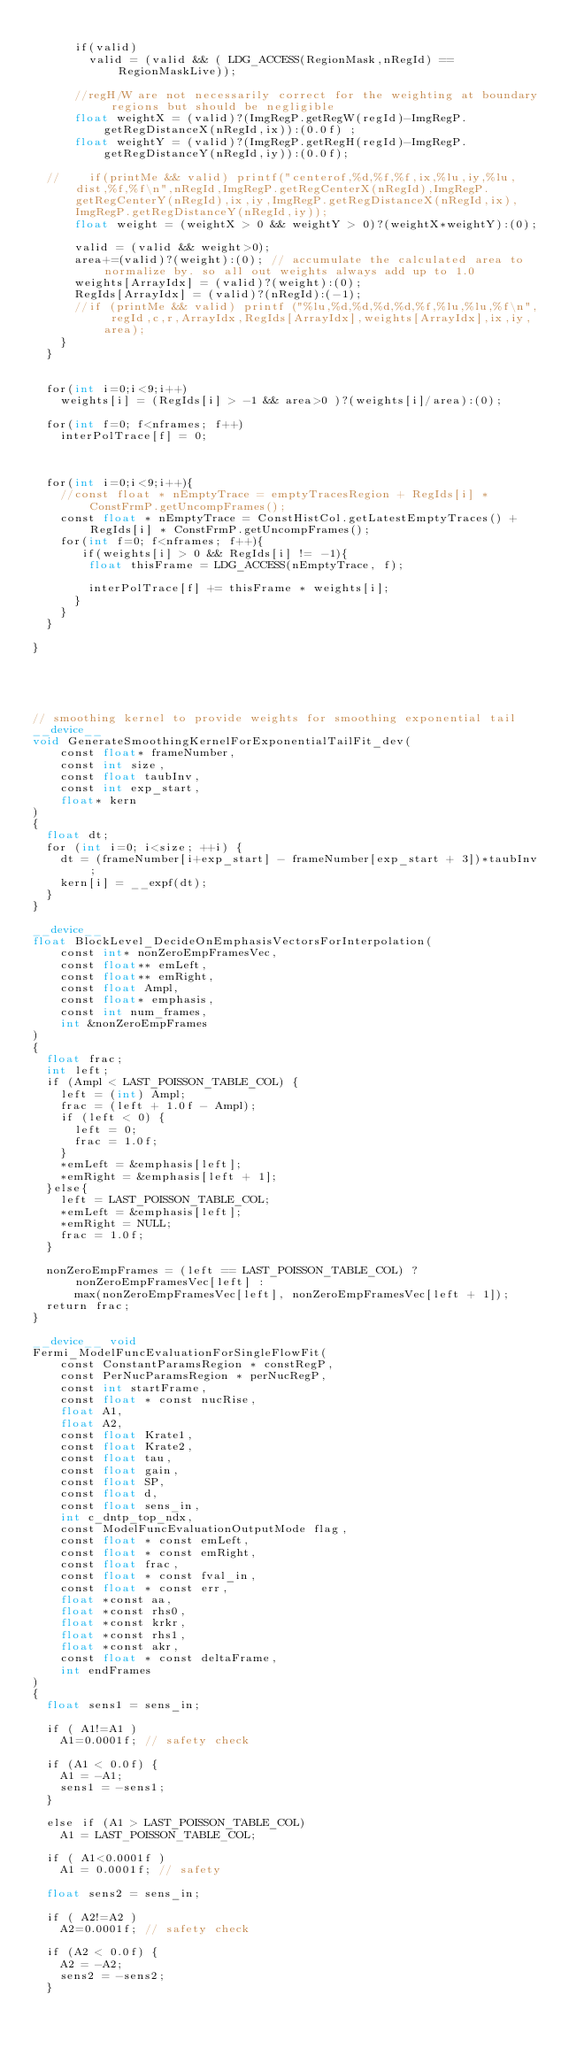<code> <loc_0><loc_0><loc_500><loc_500><_Cuda_>
      if(valid)
        valid = (valid && ( LDG_ACCESS(RegionMask,nRegId) == RegionMaskLive));

      //regH/W are not necessarily correct for the weighting at boundary regions but should be negligible
      float weightX = (valid)?(ImgRegP.getRegW(regId)-ImgRegP.getRegDistanceX(nRegId,ix)):(0.0f) ;
      float weightY = (valid)?(ImgRegP.getRegH(regId)-ImgRegP.getRegDistanceY(nRegId,iy)):(0.0f);

  //    if(printMe && valid) printf("centerof,%d,%f,%f,ix,%lu,iy,%lu,dist,%f,%f\n",nRegId,ImgRegP.getRegCenterX(nRegId),ImgRegP.getRegCenterY(nRegId),ix,iy,ImgRegP.getRegDistanceX(nRegId,ix),ImgRegP.getRegDistanceY(nRegId,iy));
      float weight = (weightX > 0 && weightY > 0)?(weightX*weightY):(0);

      valid = (valid && weight>0);
      area+=(valid)?(weight):(0); // accumulate the calculated area to normalize by. so all out weights always add up to 1.0
      weights[ArrayIdx] = (valid)?(weight):(0);
      RegIds[ArrayIdx] = (valid)?(nRegId):(-1);
      //if (printMe && valid) printf ("%lu,%d,%d,%d,%d,%f,%lu,%lu,%f\n", regId,c,r,ArrayIdx,RegIds[ArrayIdx],weights[ArrayIdx],ix,iy,area);
    }
  }


  for(int i=0;i<9;i++)
    weights[i] = (RegIds[i] > -1 && area>0 )?(weights[i]/area):(0);

  for(int f=0; f<nframes; f++)
    interPolTrace[f] = 0;



  for(int i=0;i<9;i++){
    //const float * nEmptyTrace = emptyTracesRegion + RegIds[i] * ConstFrmP.getUncompFrames();
    const float * nEmptyTrace = ConstHistCol.getLatestEmptyTraces() + RegIds[i] * ConstFrmP.getUncompFrames();
    for(int f=0; f<nframes; f++){
       if(weights[i] > 0 && RegIds[i] != -1){
        float thisFrame = LDG_ACCESS(nEmptyTrace, f);

        interPolTrace[f] += thisFrame * weights[i];
      }
    }
  }

}





// smoothing kernel to provide weights for smoothing exponential tail 
__device__
void GenerateSmoothingKernelForExponentialTailFit_dev(
    const float* frameNumber,
    const int size,
    const float taubInv,
    const int exp_start,
    float* kern
)
{
  float dt;
  for (int i=0; i<size; ++i) {
    dt = (frameNumber[i+exp_start] - frameNumber[exp_start + 3])*taubInv;
    kern[i] = __expf(dt);   
  }
}

__device__ 
float BlockLevel_DecideOnEmphasisVectorsForInterpolation(
    const int* nonZeroEmpFramesVec,
    const float** emLeft,
    const float** emRight,
    const float Ampl,
    const float* emphasis,
    const int num_frames,
    int &nonZeroEmpFrames
)
{
  float frac;
  int left;
  if (Ampl < LAST_POISSON_TABLE_COL) {
    left = (int) Ampl;
    frac = (left + 1.0f - Ampl);
    if (left < 0) {
      left = 0;
      frac = 1.0f;
    }
    *emLeft = &emphasis[left];
    *emRight = &emphasis[left + 1];
  }else{
    left = LAST_POISSON_TABLE_COL;
    *emLeft = &emphasis[left]; 
    *emRight = NULL;
    frac = 1.0f;
  }

  nonZeroEmpFrames = (left == LAST_POISSON_TABLE_COL) ? nonZeroEmpFramesVec[left] :
      max(nonZeroEmpFramesVec[left], nonZeroEmpFramesVec[left + 1]);
  return frac;
}

__device__ void
Fermi_ModelFuncEvaluationForSingleFlowFit(
    const ConstantParamsRegion * constRegP,
    const PerNucParamsRegion * perNucRegP,
    const int startFrame,
    const float * const nucRise,
    float A1,
    float A2,
    const float Krate1,
    const float Krate2,
    const float tau,
    const float gain,
    const float SP,
    const float d,
    const float sens_in,
    int c_dntp_top_ndx,
    const ModelFuncEvaluationOutputMode flag,
    const float * const emLeft,
    const float * const emRight,
    const float frac,
    const float * const fval_in,
    const float * const err,
    float *const aa,
    float *const rhs0,
    float *const krkr,
    float *const rhs1,
    float *const akr,
    const float * const deltaFrame,
    int endFrames
)
{
  float sens1 = sens_in;

  if ( A1!=A1 )
    A1=0.0001f; // safety check

  if (A1 < 0.0f) {
    A1 = -A1;
    sens1 = -sens1;
  }

  else if (A1 > LAST_POISSON_TABLE_COL)
    A1 = LAST_POISSON_TABLE_COL;

  if ( A1<0.0001f )
    A1 = 0.0001f; // safety

  float sens2 = sens_in;

  if ( A2!=A2 )
    A2=0.0001f; // safety check

  if (A2 < 0.0f) {
    A2 = -A2;
    sens2 = -sens2;
  }
</code> 